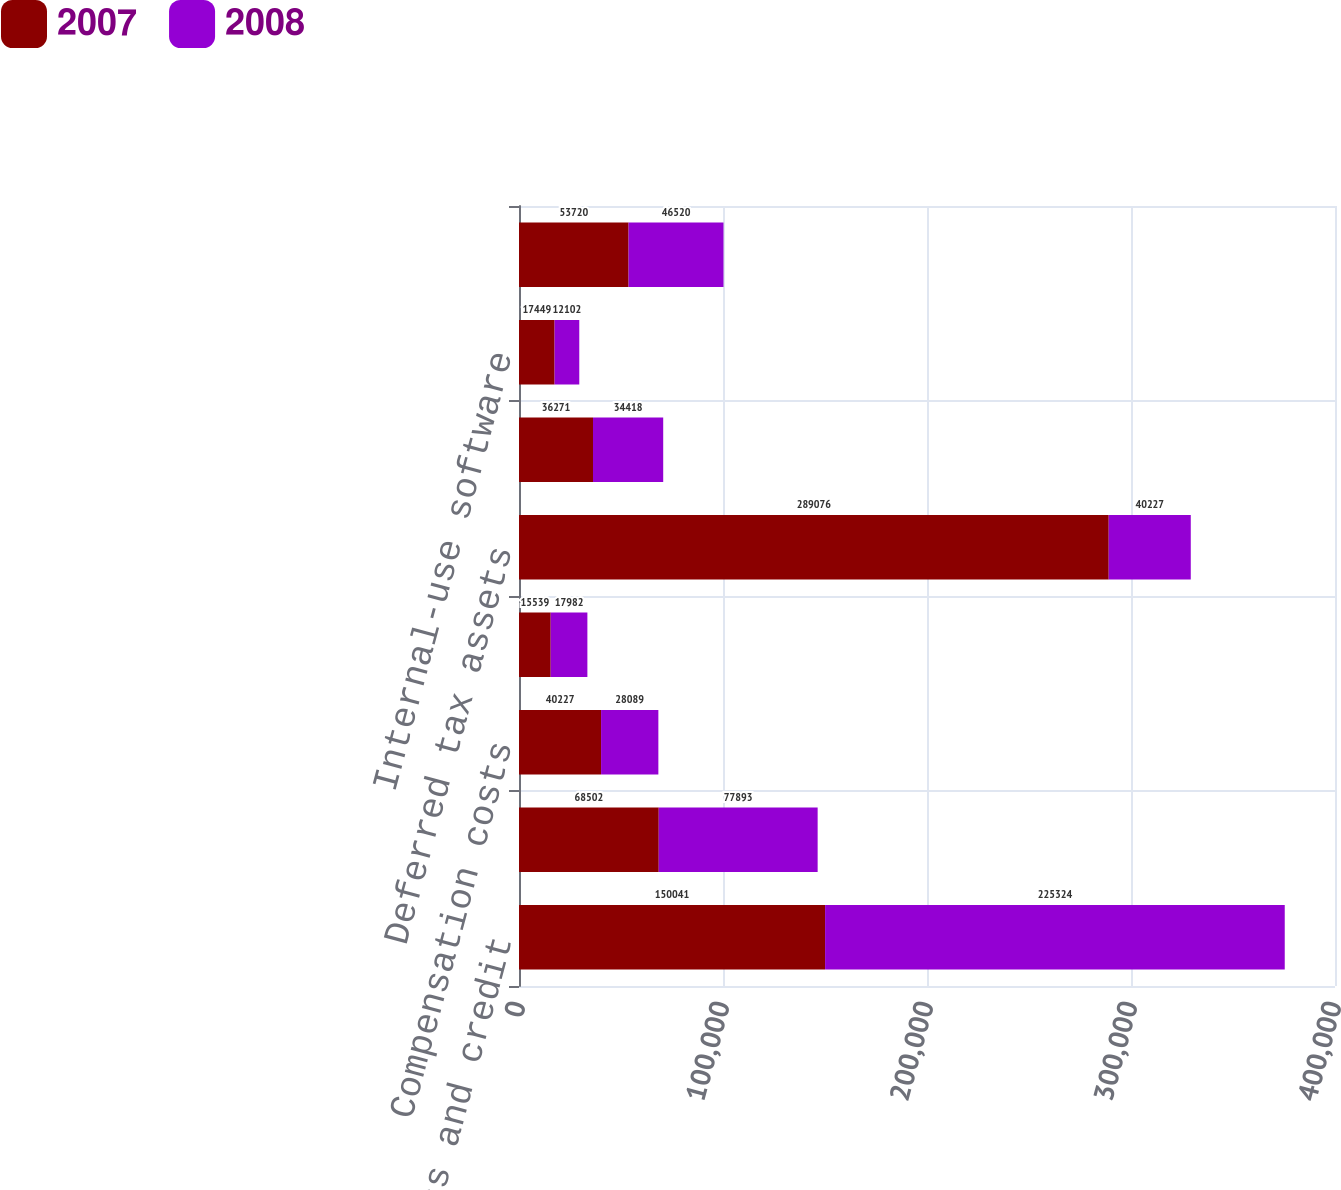Convert chart. <chart><loc_0><loc_0><loc_500><loc_500><stacked_bar_chart><ecel><fcel>Net operating loss and credit<fcel>Depreciation and amortization<fcel>Compensation costs<fcel>Other<fcel>Deferred tax assets<fcel>Acquired intangible assets not<fcel>Internal-use software<fcel>Deferred tax liabilities<nl><fcel>2007<fcel>150041<fcel>68502<fcel>40227<fcel>15539<fcel>289076<fcel>36271<fcel>17449<fcel>53720<nl><fcel>2008<fcel>225324<fcel>77893<fcel>28089<fcel>17982<fcel>40227<fcel>34418<fcel>12102<fcel>46520<nl></chart> 